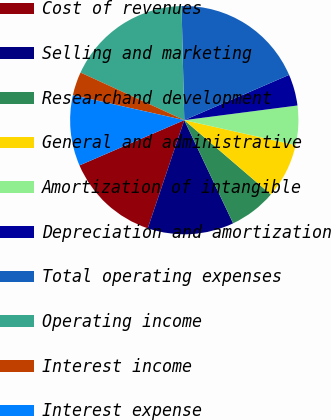Convert chart to OTSL. <chart><loc_0><loc_0><loc_500><loc_500><pie_chart><fcel>Cost of revenues<fcel>Selling and marketing<fcel>Researchand development<fcel>General and administrative<fcel>Amortization of intangible<fcel>Depreciation and amortization<fcel>Total operating expenses<fcel>Operating income<fcel>Interest income<fcel>Interest expense<nl><fcel>13.33%<fcel>12.22%<fcel>6.67%<fcel>7.78%<fcel>5.56%<fcel>4.44%<fcel>18.89%<fcel>17.78%<fcel>3.33%<fcel>10.0%<nl></chart> 